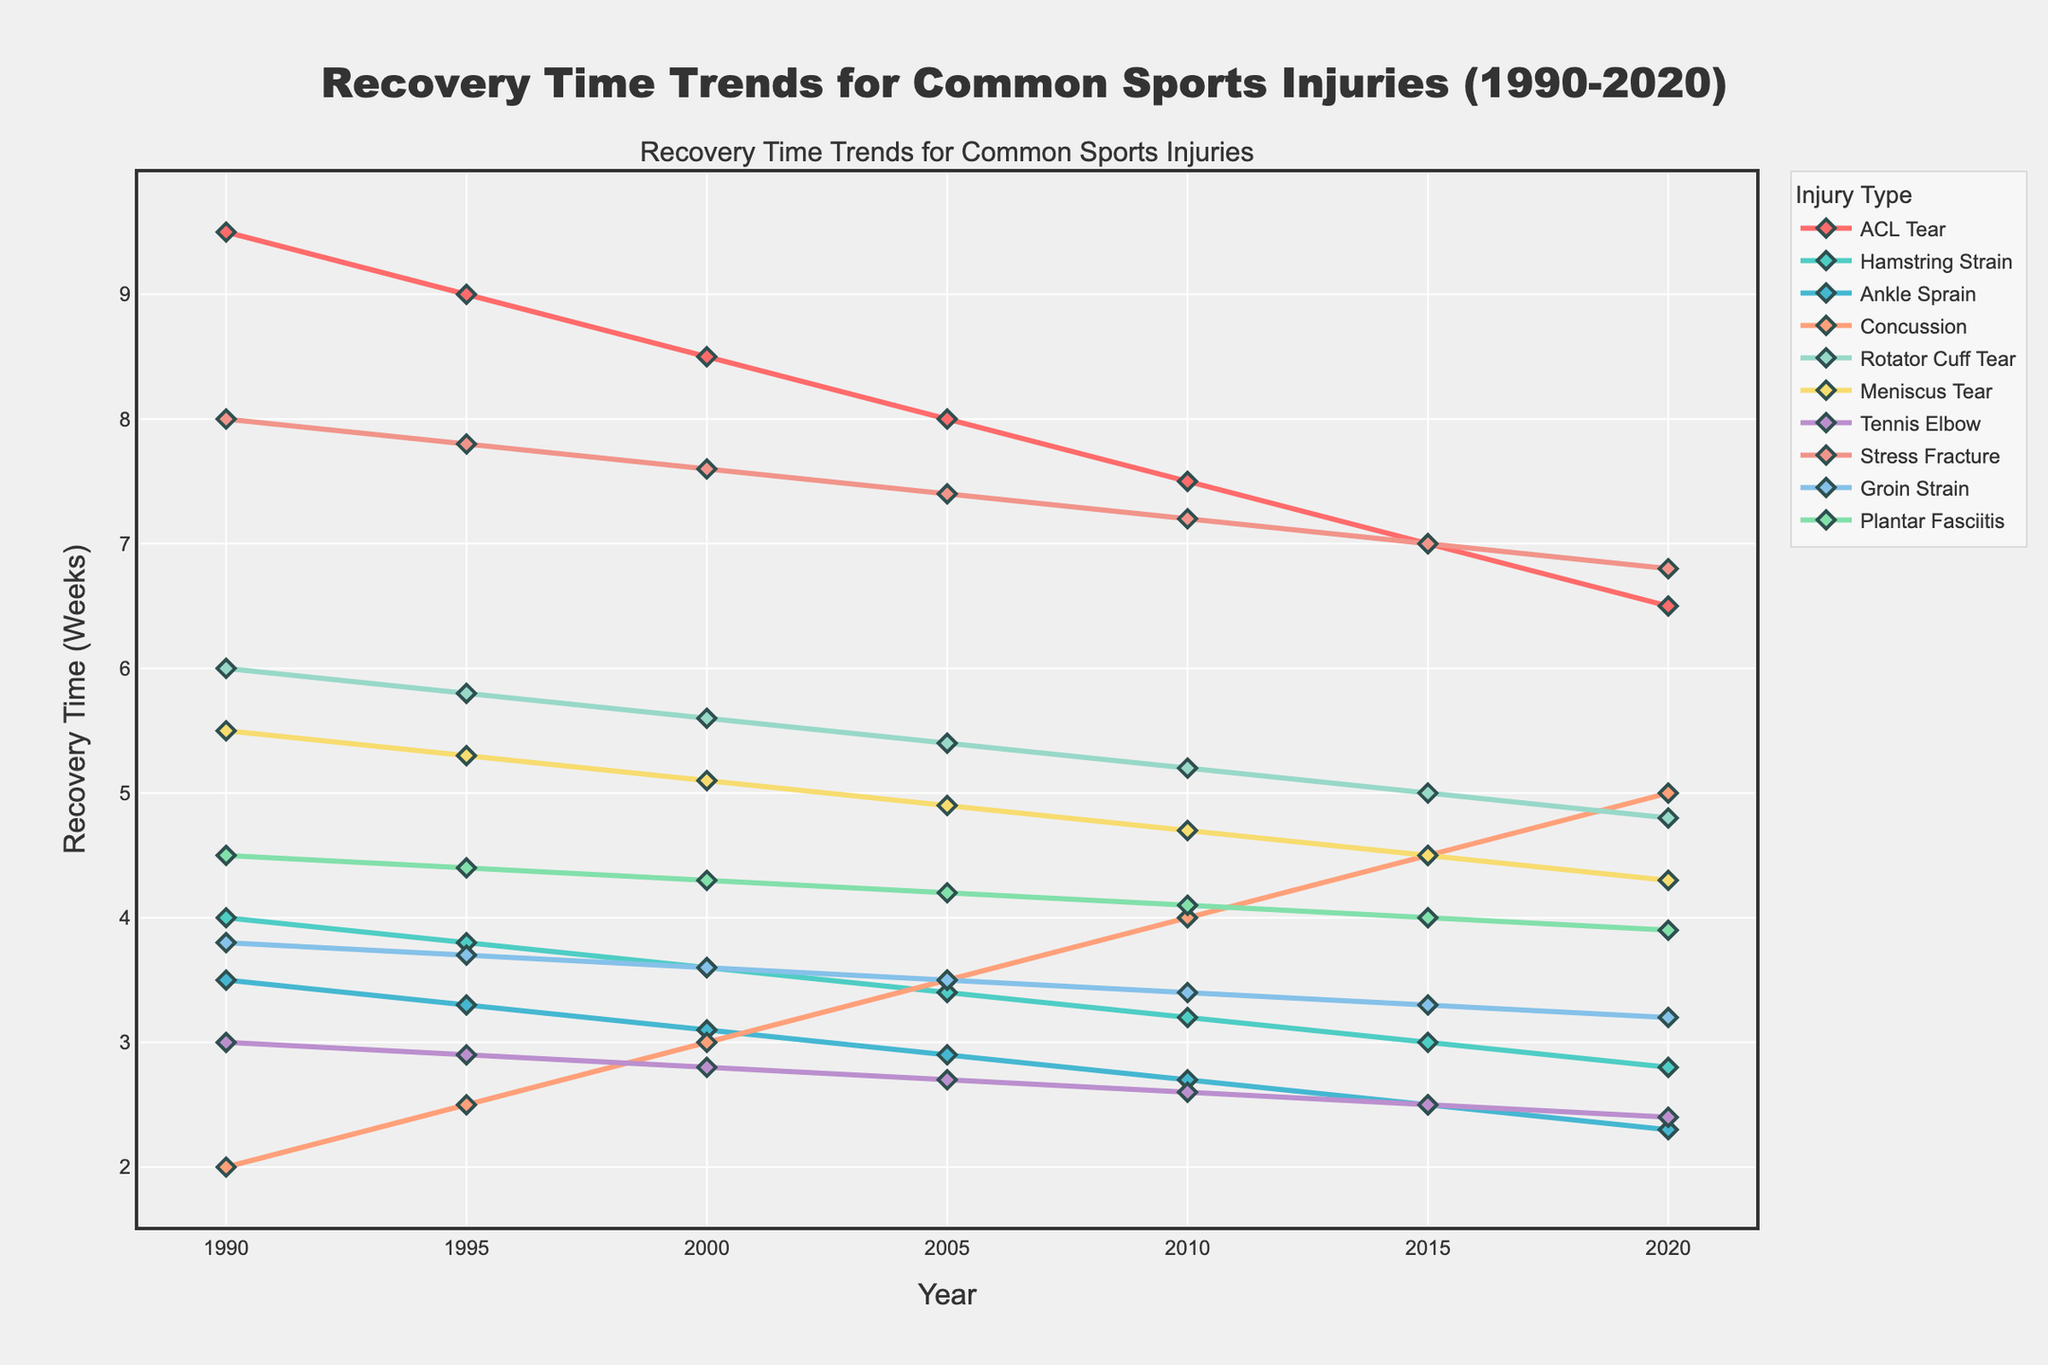Which injury type had the longest recovery time in 1990? Look at the data points for 1990 on the x-axis and identify the injury type with the highest y-axis value. ACL Tear has the longest recovery time.
Answer: ACL Tear Which injury type had the sharpest increase in recovery time? Compare the trends in the graph and identify which line has the steepest upward slope. Concussion shows the greatest increase.
Answer: Concussion What is the average recovery time for an ACL Tear over the years? Sum the recovery times for ACL Tear from 1990 to 2020 and divide by the number of data points: (9.5 + 9.0 + 8.5 + 8.0 + 7.5 + 7.0 + 6.5)/7 = 8.14 weeks
Answer: 8.14 weeks How has the recovery time for a Stress Fracture changed from 1990 to 2020? Subtract the recovery time in 2020 from the recovery time in 1990 for Stress Fracture: 8.0 - 6.8 = 1.2 weeks. Recovery time has decreased.
Answer: Decreased by 1.2 weeks Which injury type had the largest decrease in recovery time between 1990 and 2020? Calculate the difference in recovery time for each injury type, then identify the largest value. ACL Tear decrease: 9.5 - 6.5 = 3 weeks, which is the largest.
Answer: ACL Tear Which injuries had a decreasing trend in recovery time from 1990 to 2020? Identify the lines that slope downward from left to right. Injuries are ACL Tear, Hamstring Strain, Ankle Sprain, Rotator Cuff Tear, Meniscus Tear, Tennis Elbow, Stress Fracture, Groin Strain, and Plantar Fasciitis.
Answer: ACL Tear, Hamstring Strain, Ankle Sprain, Rotator Cuff Tear, Meniscus Tear, Tennis Elbow, Stress Fracture, Groin Strain, Plantar Fasciitis What is the total recovery time for Rotator Cuff Tear from 1990 to 2020? Sum the recovery times for Rotator Cuff Tear from 1990 to 2020: 6.0 + 5.8 + 5.6 + 5.4 + 5.2 + 5.0 + 4.8 = 37.8 weeks.
Answer: 37.8 weeks Which injury types have converging recovery times by 2020? Observe the lines that come closer together in 2020. Ankle Sprain, Tennis Elbow, Concussion have converging recovery times by 2020 around 2.3 to 2.4 weeks (excluding Concussion)
Answer: Ankle Sprain, Tennis Elbow How does the recovery time for Concussion compare to other injury types in recent years? Look at the trend lines for Concussion and compare the y-axis values with other injury types around 2020. Concussion recovery time increased, unlike most others.
Answer: Increased significantly 